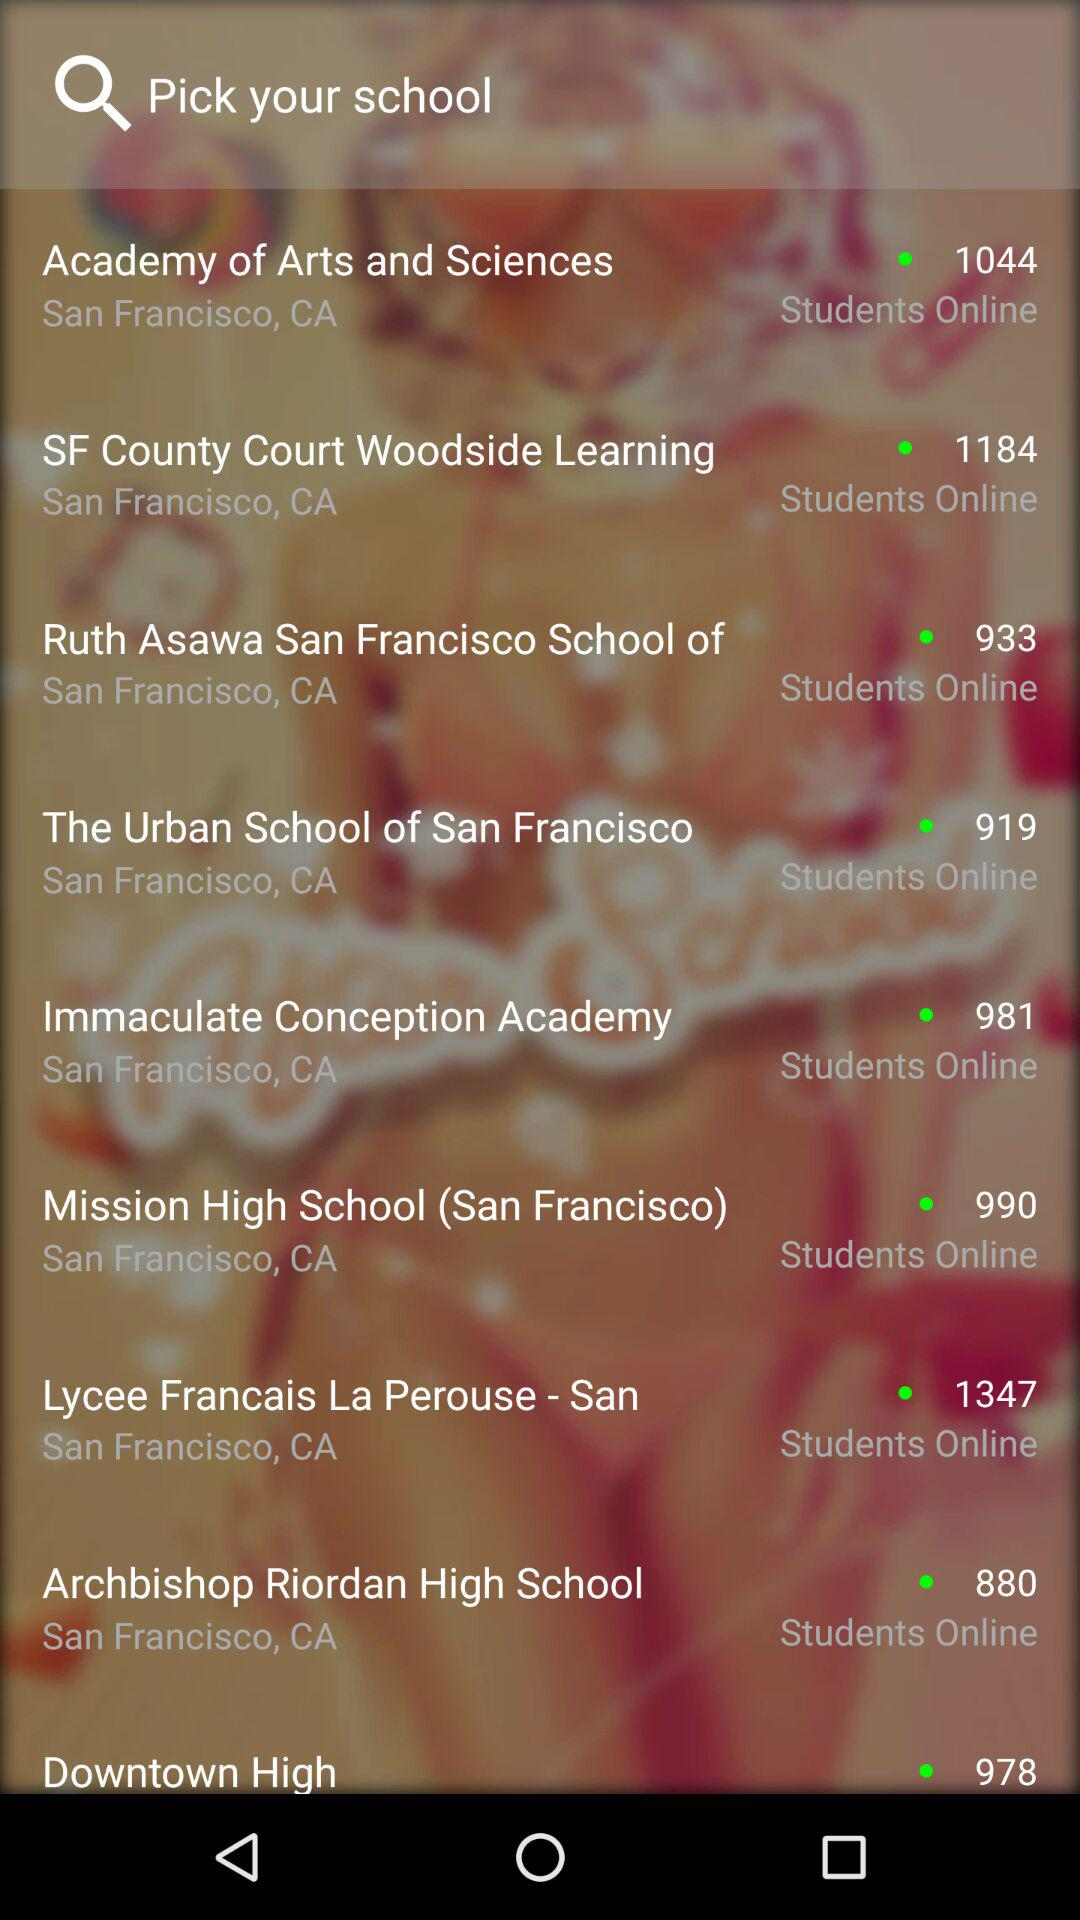What is the location of the "Immaculate Conception Academy"? The location is San Francisco, CA. 